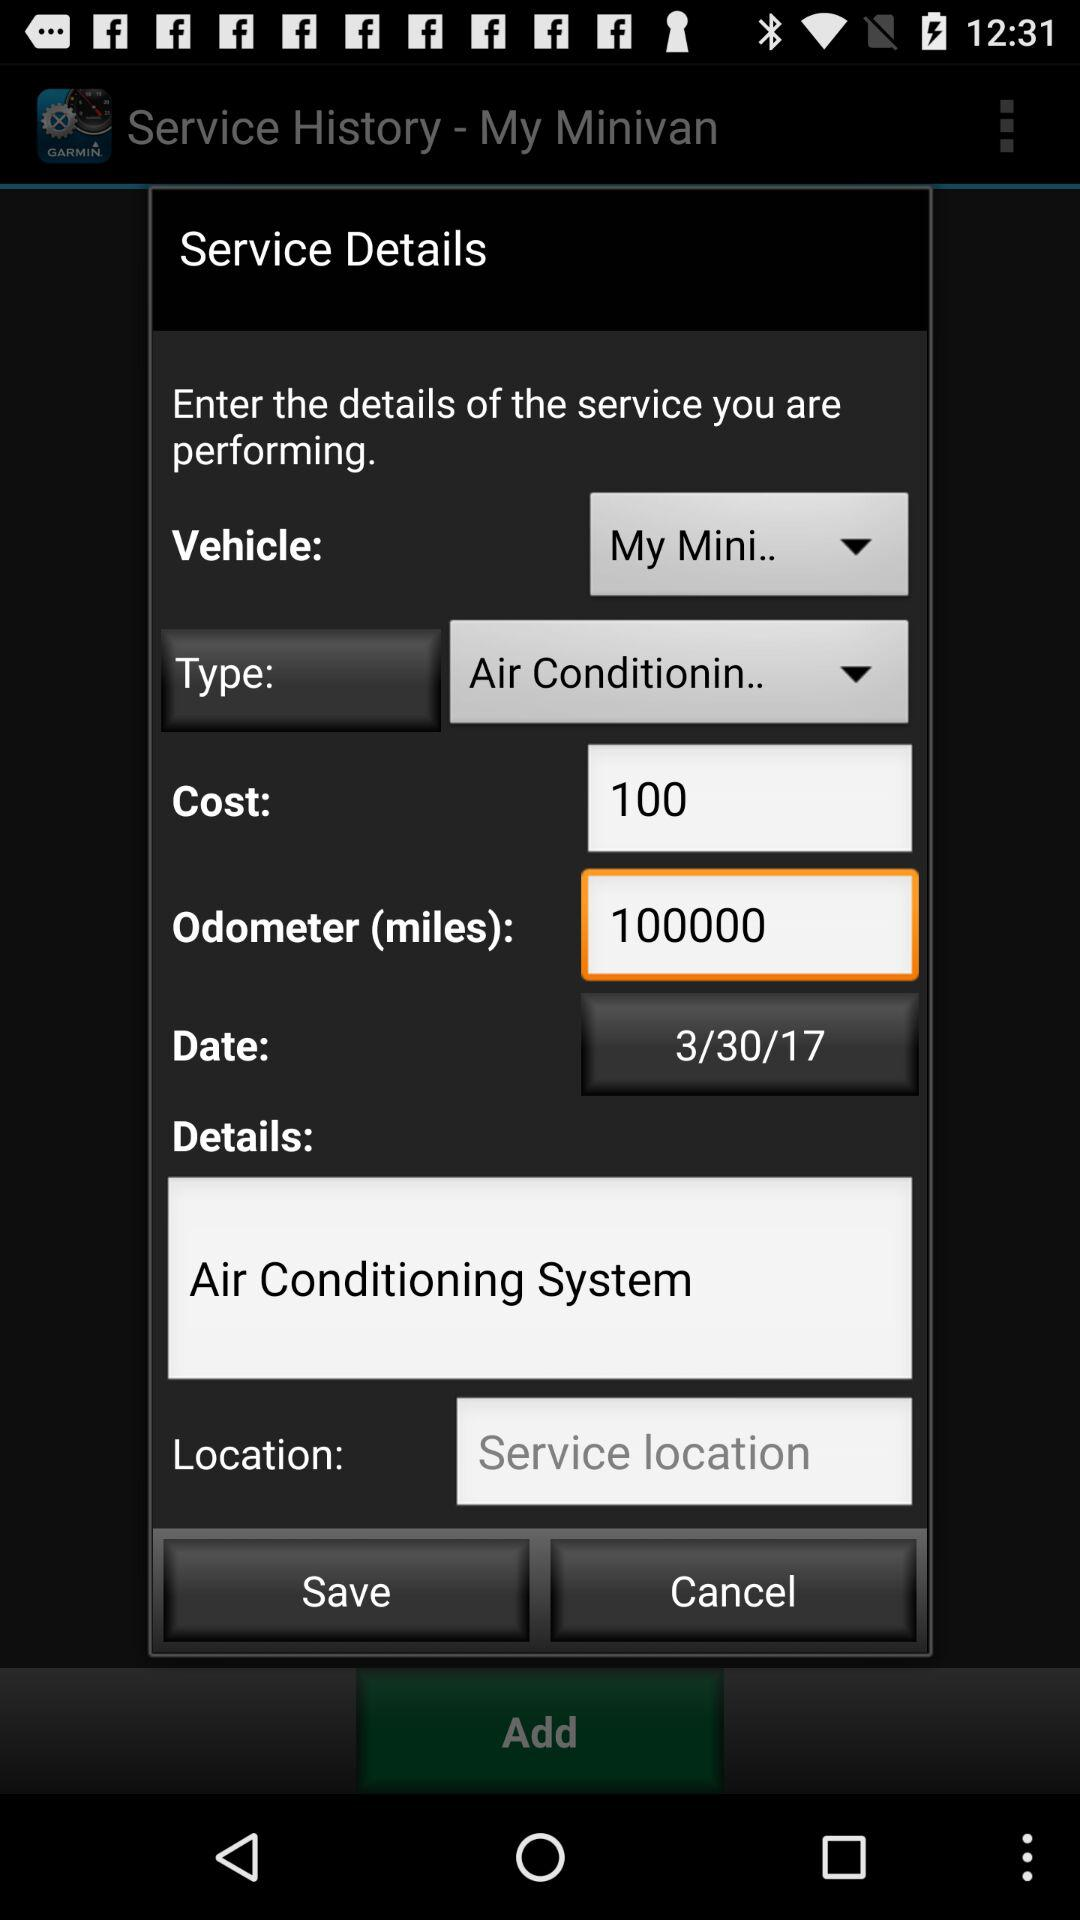What is the service type? The service type is "Air Conditionin..". 